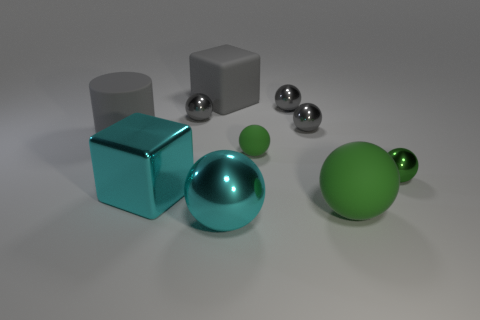Subtract all yellow cylinders. How many gray balls are left? 3 Subtract 2 balls. How many balls are left? 5 Subtract all big metal spheres. How many spheres are left? 6 Subtract all gray balls. How many balls are left? 4 Subtract all yellow balls. Subtract all yellow cubes. How many balls are left? 7 Subtract all blocks. How many objects are left? 8 Subtract 0 yellow cubes. How many objects are left? 10 Subtract all gray balls. Subtract all green spheres. How many objects are left? 4 Add 6 gray blocks. How many gray blocks are left? 7 Add 9 cyan metallic blocks. How many cyan metallic blocks exist? 10 